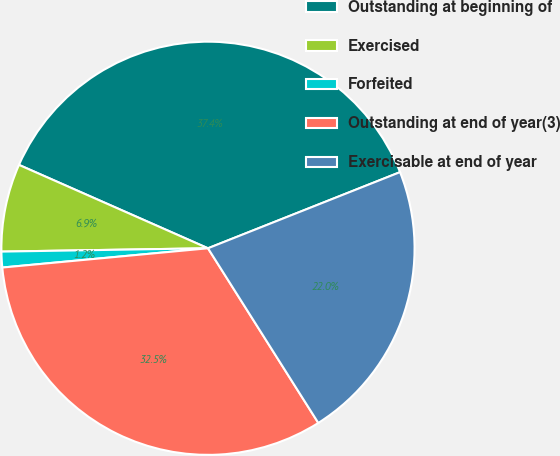Convert chart to OTSL. <chart><loc_0><loc_0><loc_500><loc_500><pie_chart><fcel>Outstanding at beginning of<fcel>Exercised<fcel>Forfeited<fcel>Outstanding at end of year(3)<fcel>Exercisable at end of year<nl><fcel>37.38%<fcel>6.87%<fcel>1.23%<fcel>32.48%<fcel>22.04%<nl></chart> 